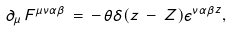<formula> <loc_0><loc_0><loc_500><loc_500>\partial _ { \mu } \, F ^ { \mu \nu \alpha \beta } \, = \, - \, \theta \delta ( z \, - \, Z ) \epsilon ^ { \nu \alpha \beta z } ,</formula> 